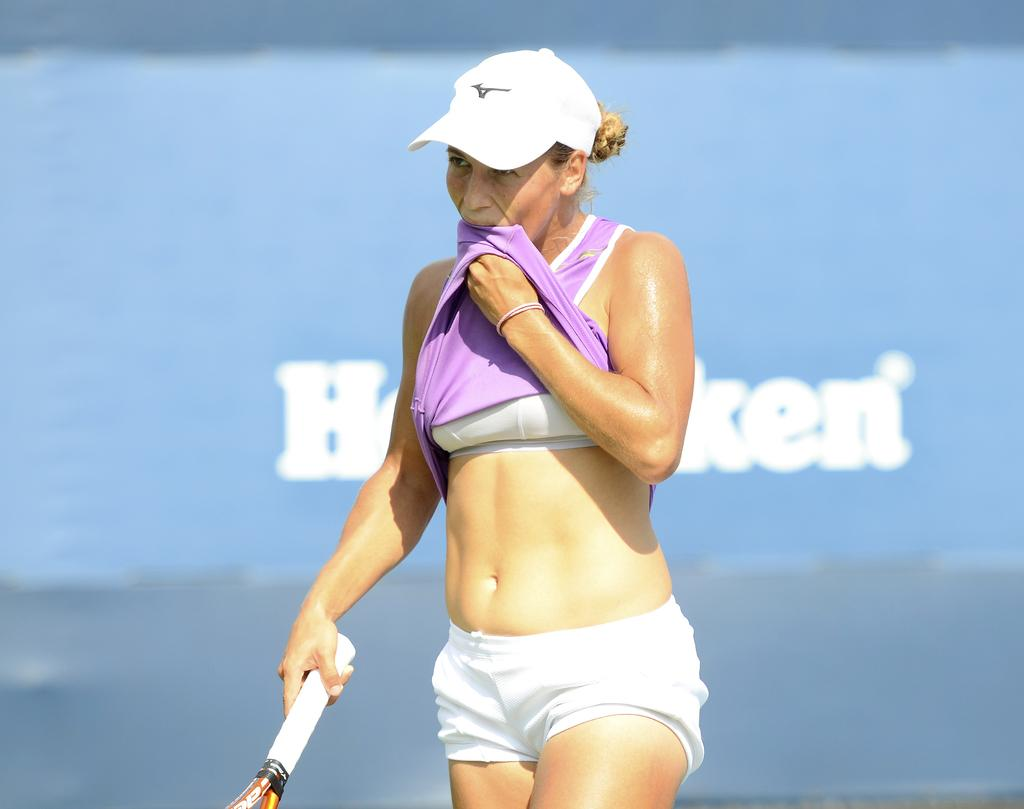Who is the main subject in the image? There is a woman in the image. What is the woman wearing on her head? The woman is wearing a white color cap. How many eggs are visible in the image? There are no eggs present in the image. What type of footwear is the woman wearing in the image? The provided facts do not mention any footwear worn by the woman in the image. 